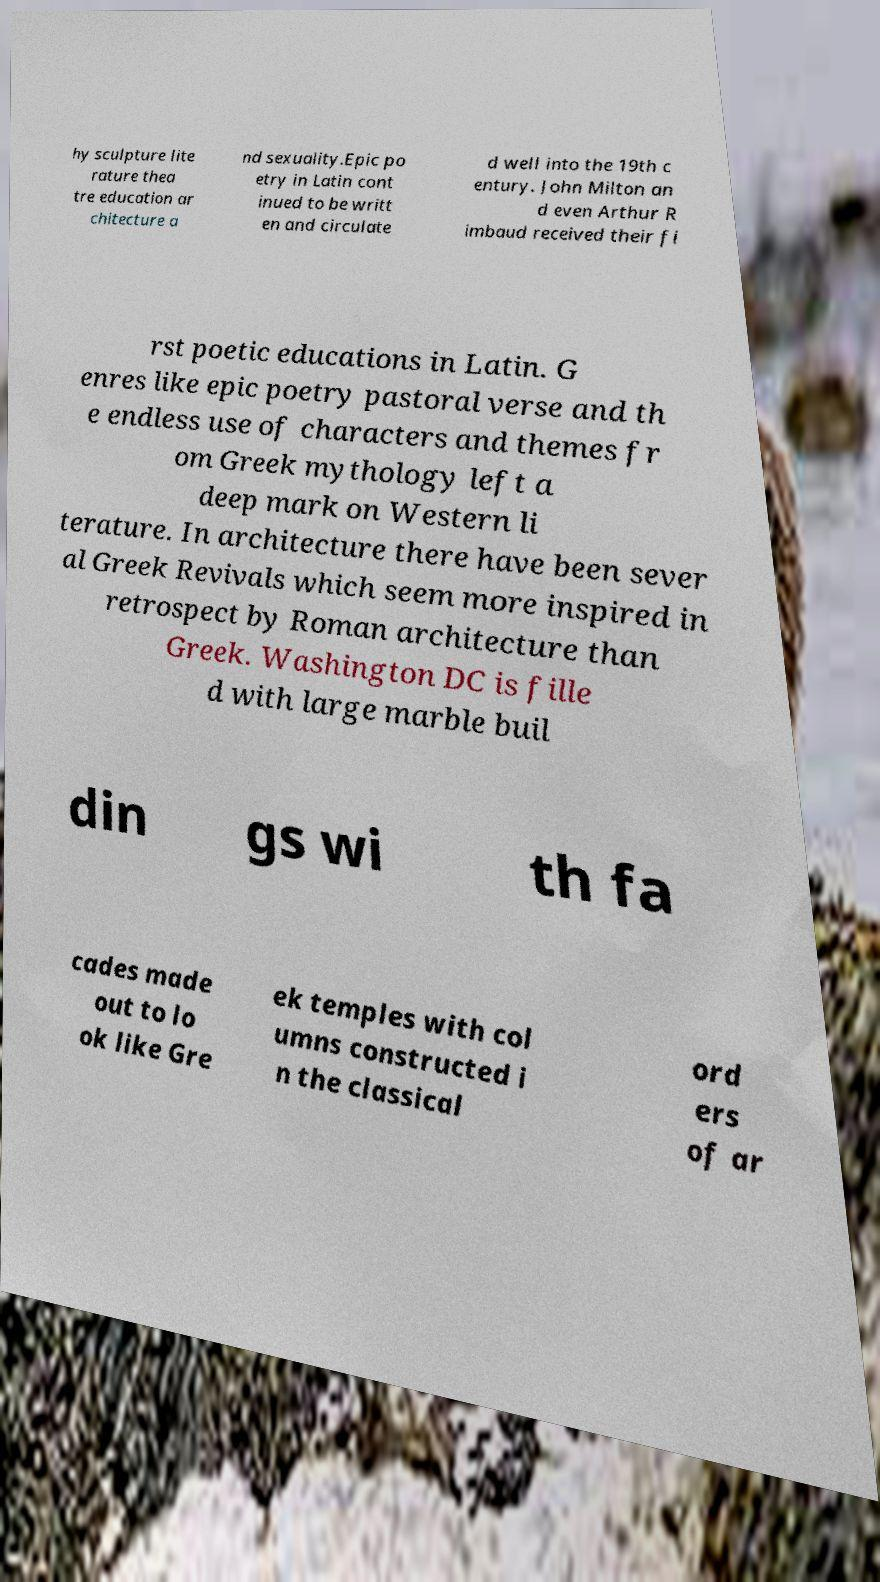What messages or text are displayed in this image? I need them in a readable, typed format. hy sculpture lite rature thea tre education ar chitecture a nd sexuality.Epic po etry in Latin cont inued to be writt en and circulate d well into the 19th c entury. John Milton an d even Arthur R imbaud received their fi rst poetic educations in Latin. G enres like epic poetry pastoral verse and th e endless use of characters and themes fr om Greek mythology left a deep mark on Western li terature. In architecture there have been sever al Greek Revivals which seem more inspired in retrospect by Roman architecture than Greek. Washington DC is fille d with large marble buil din gs wi th fa cades made out to lo ok like Gre ek temples with col umns constructed i n the classical ord ers of ar 